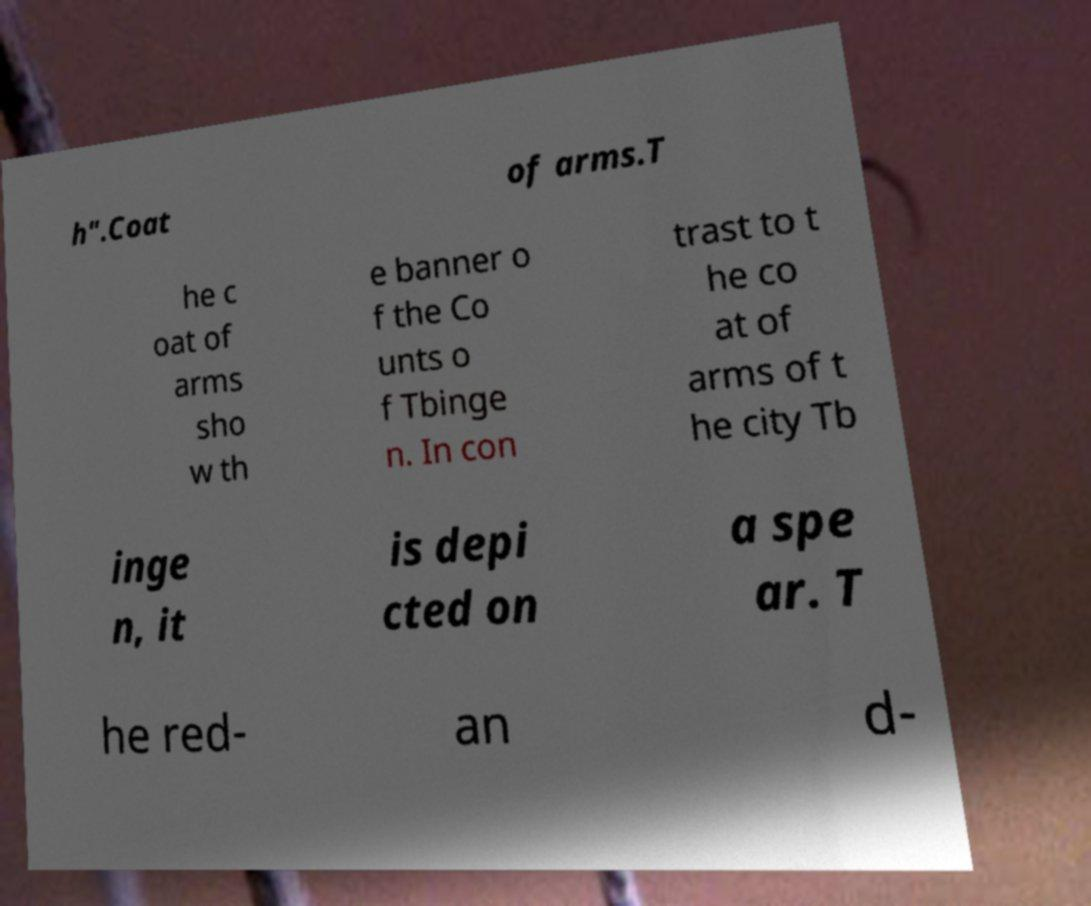I need the written content from this picture converted into text. Can you do that? h".Coat of arms.T he c oat of arms sho w th e banner o f the Co unts o f Tbinge n. In con trast to t he co at of arms of t he city Tb inge n, it is depi cted on a spe ar. T he red- an d- 